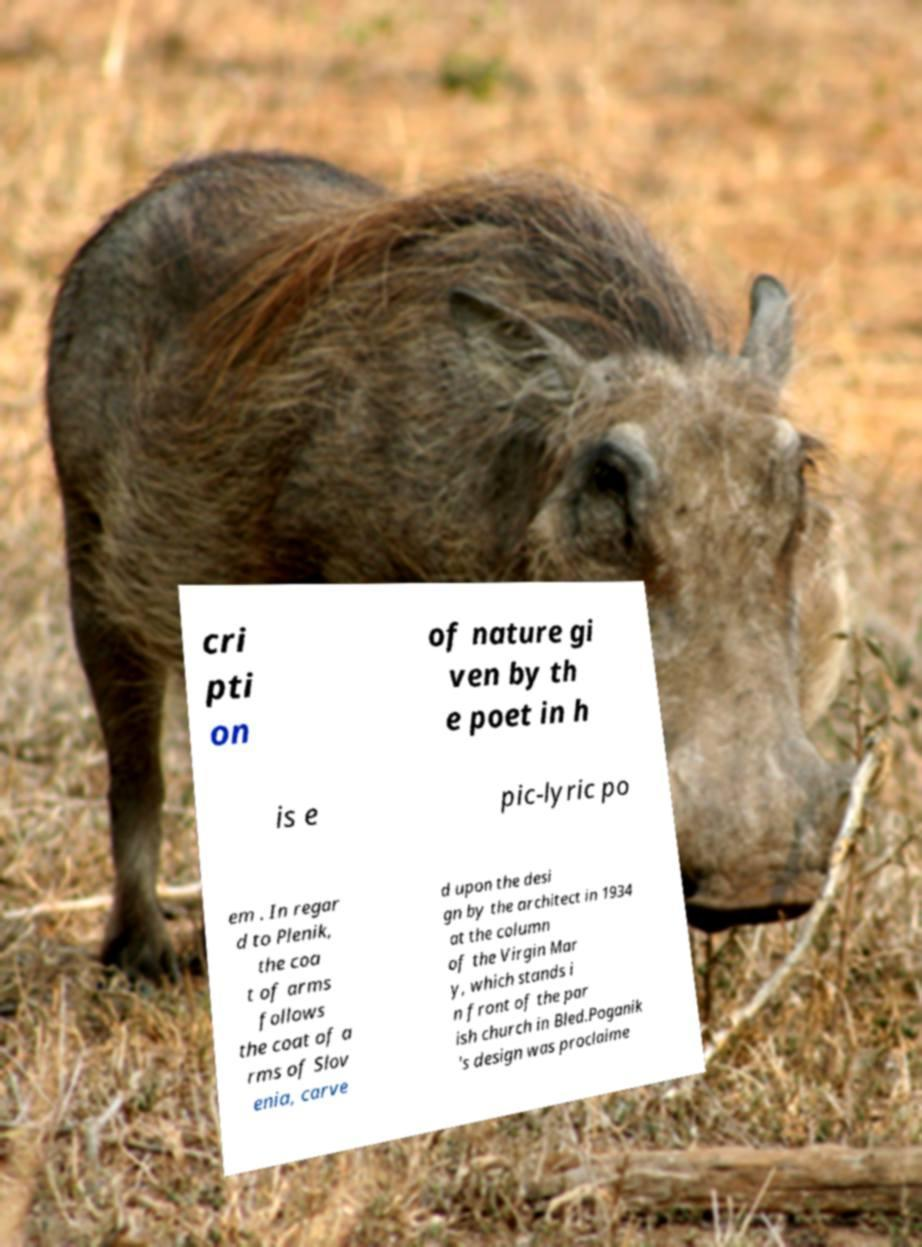There's text embedded in this image that I need extracted. Can you transcribe it verbatim? cri pti on of nature gi ven by th e poet in h is e pic-lyric po em . In regar d to Plenik, the coa t of arms follows the coat of a rms of Slov enia, carve d upon the desi gn by the architect in 1934 at the column of the Virgin Mar y, which stands i n front of the par ish church in Bled.Poganik 's design was proclaime 